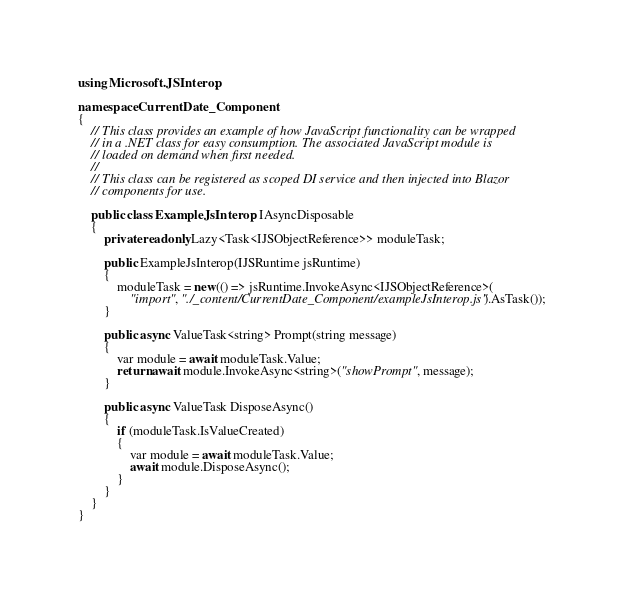<code> <loc_0><loc_0><loc_500><loc_500><_C#_>using Microsoft.JSInterop;

namespace CurrentDate_Component
{
    // This class provides an example of how JavaScript functionality can be wrapped
    // in a .NET class for easy consumption. The associated JavaScript module is
    // loaded on demand when first needed.
    //
    // This class can be registered as scoped DI service and then injected into Blazor
    // components for use.

    public class ExampleJsInterop : IAsyncDisposable
    {
        private readonly Lazy<Task<IJSObjectReference>> moduleTask;

        public ExampleJsInterop(IJSRuntime jsRuntime)
        {
            moduleTask = new(() => jsRuntime.InvokeAsync<IJSObjectReference>(
                "import", "./_content/CurrentDate_Component/exampleJsInterop.js").AsTask());
        }

        public async ValueTask<string> Prompt(string message)
        {
            var module = await moduleTask.Value;
            return await module.InvokeAsync<string>("showPrompt", message);
        }

        public async ValueTask DisposeAsync()
        {
            if (moduleTask.IsValueCreated)
            {
                var module = await moduleTask.Value;
                await module.DisposeAsync();
            }
        }
    }
}</code> 